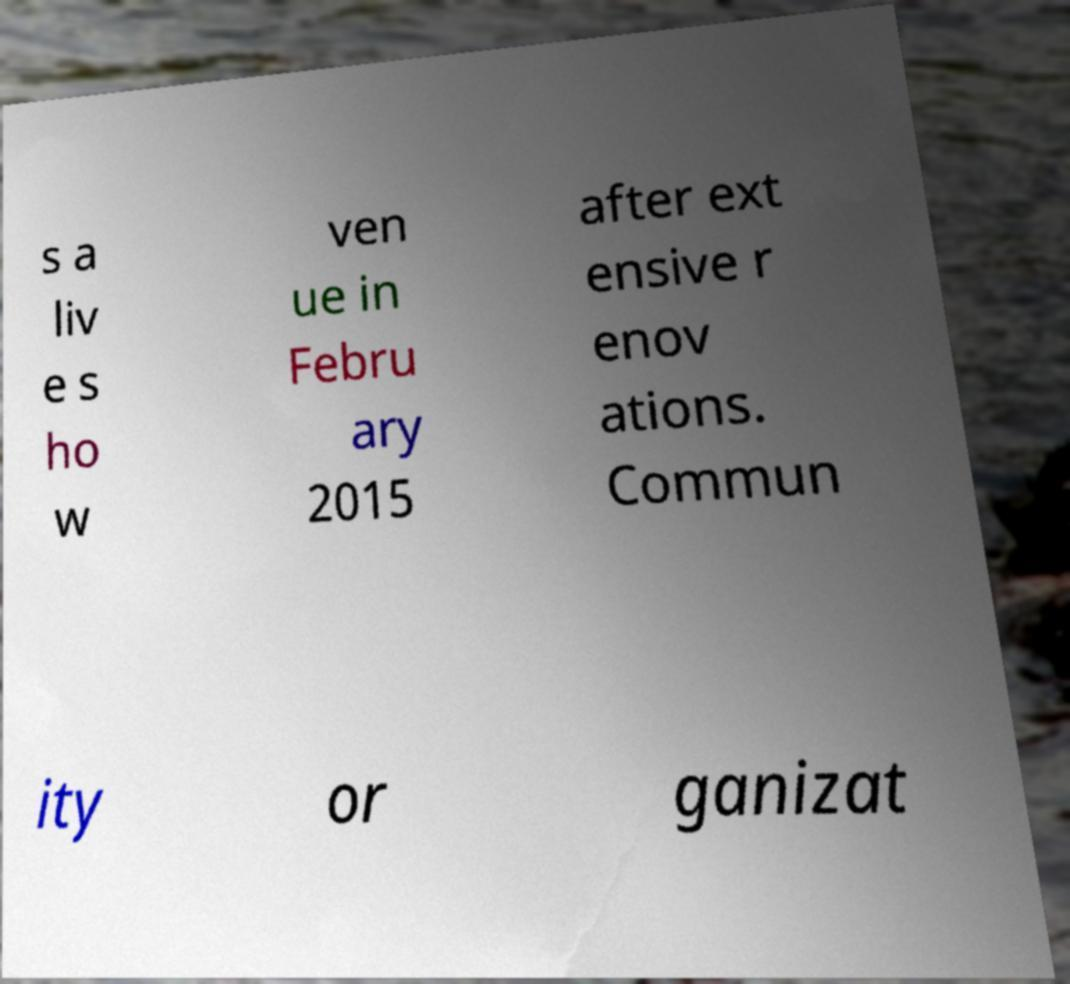There's text embedded in this image that I need extracted. Can you transcribe it verbatim? s a liv e s ho w ven ue in Febru ary 2015 after ext ensive r enov ations. Commun ity or ganizat 